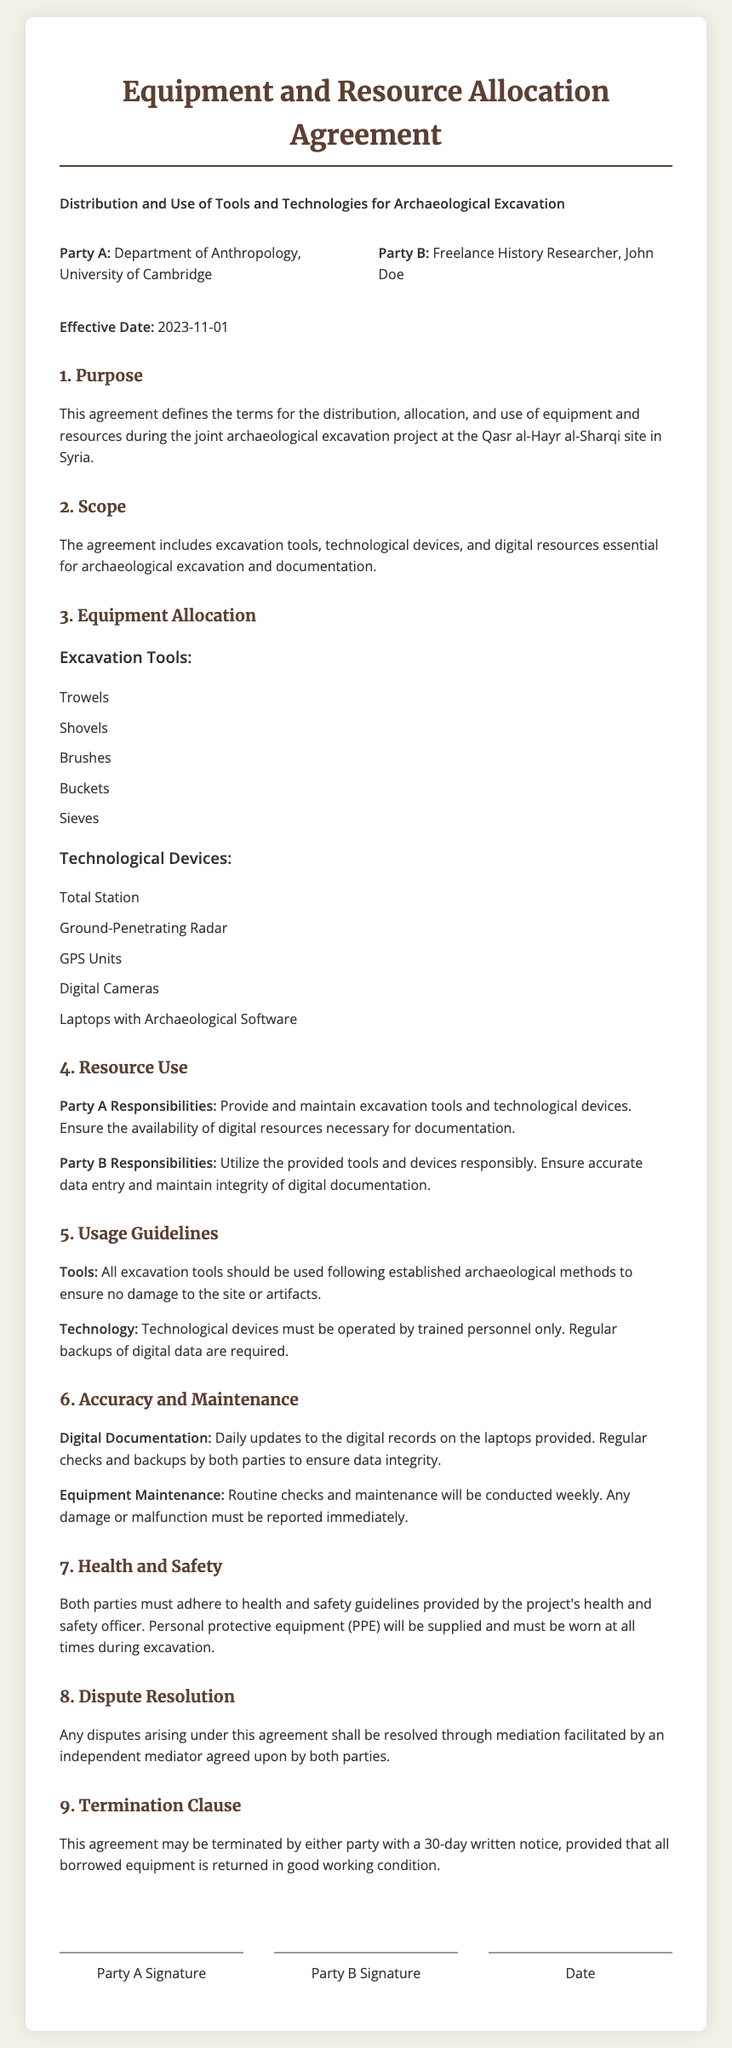What is the effective date of the agreement? The effective date is clearly stated in the document, which is 2023-11-01.
Answer: 2023-11-01 Who are the parties involved in this agreement? The document specifies the two parties involved: the Department of Anthropology, University of Cambridge, and Freelance History Researcher, John Doe.
Answer: Department of Anthropology, University of Cambridge and Freelance History Researcher, John Doe What is Party A's responsibility regarding equipment? Party A's responsibilities include providing and maintaining excavation tools and technological devices.
Answer: Provide and maintain excavation tools and technological devices How often will equipment maintenance checks be conducted? The document states that routine checks and maintenance will be conducted weekly.
Answer: Weekly What must both parties do for digital documentation? Both parties are required to perform regular backups of digital data for integrity.
Answer: Regular backups of digital data What is the duration of the termination notice? The document specifies that a 30-day written notice is required for termination by either party.
Answer: 30-day written notice Which technological device is NOT mentioned in the agreement? The agreement includes specific items; any item not listed would be excluded, such as drones or excavators.
Answer: Drones (or Excavators) What will be supplied for personal safety during the excavation? The document mentions that personal protective equipment (PPE) will be supplied for safety.
Answer: Personal protective equipment (PPE) 